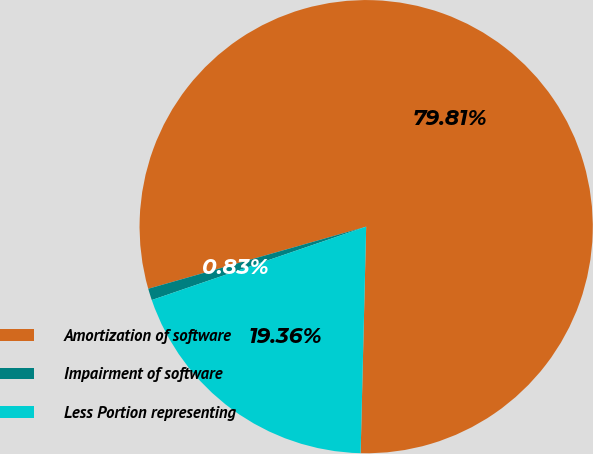Convert chart. <chart><loc_0><loc_0><loc_500><loc_500><pie_chart><fcel>Amortization of software<fcel>Impairment of software<fcel>Less Portion representing<nl><fcel>79.8%<fcel>0.83%<fcel>19.36%<nl></chart> 